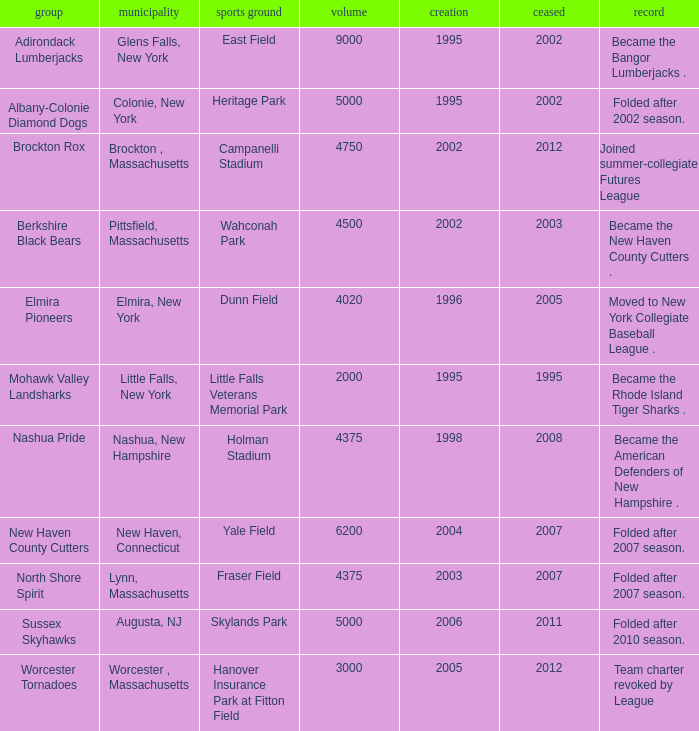What is the maximum founded year of the Worcester Tornadoes? 2005.0. 